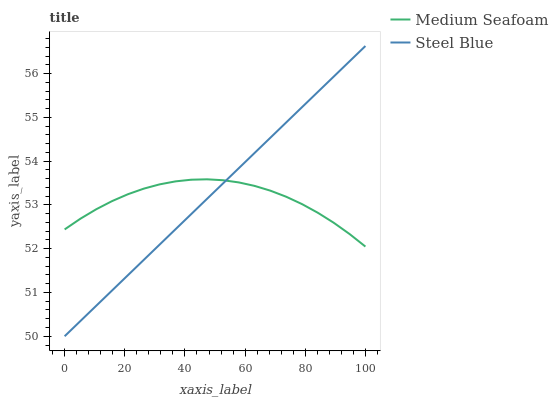Does Medium Seafoam have the minimum area under the curve?
Answer yes or no. Yes. Does Steel Blue have the maximum area under the curve?
Answer yes or no. Yes. Does Steel Blue have the minimum area under the curve?
Answer yes or no. No. Is Steel Blue the smoothest?
Answer yes or no. Yes. Is Medium Seafoam the roughest?
Answer yes or no. Yes. Is Steel Blue the roughest?
Answer yes or no. No. Does Steel Blue have the lowest value?
Answer yes or no. Yes. Does Steel Blue have the highest value?
Answer yes or no. Yes. Does Medium Seafoam intersect Steel Blue?
Answer yes or no. Yes. Is Medium Seafoam less than Steel Blue?
Answer yes or no. No. Is Medium Seafoam greater than Steel Blue?
Answer yes or no. No. 